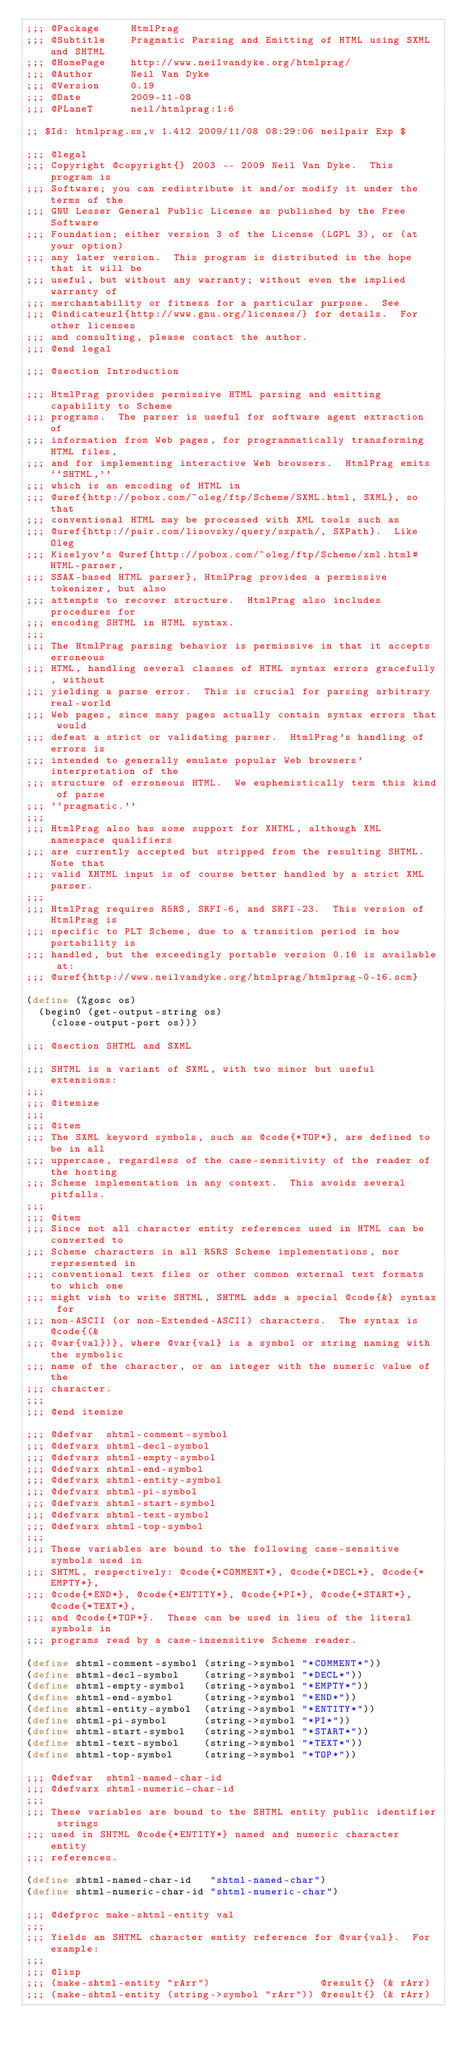Convert code to text. <code><loc_0><loc_0><loc_500><loc_500><_Scheme_>;;; @Package     HtmlPrag
;;; @Subtitle    Pragmatic Parsing and Emitting of HTML using SXML and SHTML
;;; @HomePage    http://www.neilvandyke.org/htmlprag/
;;; @Author      Neil Van Dyke
;;; @Version     0.19
;;; @Date        2009-11-08
;;; @PLaneT      neil/htmlprag:1:6

;; $Id: htmlprag.ss,v 1.412 2009/11/08 08:29:06 neilpair Exp $

;;; @legal
;;; Copyright @copyright{} 2003 -- 2009 Neil Van Dyke.  This program is
;;; Software; you can redistribute it and/or modify it under the terms of the
;;; GNU Lesser General Public License as published by the Free Software
;;; Foundation; either version 3 of the License (LGPL 3), or (at your option)
;;; any later version.  This program is distributed in the hope that it will be
;;; useful, but without any warranty; without even the implied warranty of
;;; merchantability or fitness for a particular purpose.  See
;;; @indicateurl{http://www.gnu.org/licenses/} for details.  For other licenses
;;; and consulting, please contact the author.
;;; @end legal

;;; @section Introduction

;;; HtmlPrag provides permissive HTML parsing and emitting capability to Scheme
;;; programs.  The parser is useful for software agent extraction of
;;; information from Web pages, for programmatically transforming HTML files,
;;; and for implementing interactive Web browsers.  HtmlPrag emits ``SHTML,''
;;; which is an encoding of HTML in
;;; @uref{http://pobox.com/~oleg/ftp/Scheme/SXML.html, SXML}, so that
;;; conventional HTML may be processed with XML tools such as
;;; @uref{http://pair.com/lisovsky/query/sxpath/, SXPath}.  Like Oleg
;;; Kiselyov's @uref{http://pobox.com/~oleg/ftp/Scheme/xml.html#HTML-parser,
;;; SSAX-based HTML parser}, HtmlPrag provides a permissive tokenizer, but also
;;; attempts to recover structure.  HtmlPrag also includes procedures for
;;; encoding SHTML in HTML syntax.
;;;
;;; The HtmlPrag parsing behavior is permissive in that it accepts erroneous
;;; HTML, handling several classes of HTML syntax errors gracefully, without
;;; yielding a parse error.  This is crucial for parsing arbitrary real-world
;;; Web pages, since many pages actually contain syntax errors that would
;;; defeat a strict or validating parser.  HtmlPrag's handling of errors is
;;; intended to generally emulate popular Web browsers' interpretation of the
;;; structure of erroneous HTML.  We euphemistically term this kind of parse
;;; ``pragmatic.''
;;;
;;; HtmlPrag also has some support for XHTML, although XML namespace qualifiers
;;; are currently accepted but stripped from the resulting SHTML.  Note that
;;; valid XHTML input is of course better handled by a strict XML parser.
;;;
;;; HtmlPrag requires R5RS, SRFI-6, and SRFI-23.  This version of HtmlPrag is
;;; specific to PLT Scheme, due to a transition period in how portability is
;;; handled, but the exceedingly portable version 0.16 is available at:
;;; @uref{http://www.neilvandyke.org/htmlprag/htmlprag-0-16.scm}

(define (%gosc os)
  (begin0 (get-output-string os)
    (close-output-port os)))

;;; @section SHTML and SXML

;;; SHTML is a variant of SXML, with two minor but useful extensions:
;;;
;;; @itemize
;;;
;;; @item
;;; The SXML keyword symbols, such as @code{*TOP*}, are defined to be in all
;;; uppercase, regardless of the case-sensitivity of the reader of the hosting
;;; Scheme implementation in any context.  This avoids several pitfalls.
;;;
;;; @item
;;; Since not all character entity references used in HTML can be converted to
;;; Scheme characters in all R5RS Scheme implementations, nor represented in
;;; conventional text files or other common external text formats to which one
;;; might wish to write SHTML, SHTML adds a special @code{&} syntax for
;;; non-ASCII (or non-Extended-ASCII) characters.  The syntax is @code{(&
;;; @var{val})}, where @var{val} is a symbol or string naming with the symbolic
;;; name of the character, or an integer with the numeric value of the
;;; character.
;;;
;;; @end itemize

;;; @defvar  shtml-comment-symbol
;;; @defvarx shtml-decl-symbol
;;; @defvarx shtml-empty-symbol
;;; @defvarx shtml-end-symbol
;;; @defvarx shtml-entity-symbol
;;; @defvarx shtml-pi-symbol
;;; @defvarx shtml-start-symbol
;;; @defvarx shtml-text-symbol
;;; @defvarx shtml-top-symbol
;;;
;;; These variables are bound to the following case-sensitive symbols used in
;;; SHTML, respectively: @code{*COMMENT*}, @code{*DECL*}, @code{*EMPTY*},
;;; @code{*END*}, @code{*ENTITY*}, @code{*PI*}, @code{*START*}, @code{*TEXT*},
;;; and @code{*TOP*}.  These can be used in lieu of the literal symbols in
;;; programs read by a case-insensitive Scheme reader.

(define shtml-comment-symbol (string->symbol "*COMMENT*"))
(define shtml-decl-symbol    (string->symbol "*DECL*"))
(define shtml-empty-symbol   (string->symbol "*EMPTY*"))
(define shtml-end-symbol     (string->symbol "*END*"))
(define shtml-entity-symbol  (string->symbol "*ENTITY*"))
(define shtml-pi-symbol      (string->symbol "*PI*"))
(define shtml-start-symbol   (string->symbol "*START*"))
(define shtml-text-symbol    (string->symbol "*TEXT*"))
(define shtml-top-symbol     (string->symbol "*TOP*"))

;;; @defvar  shtml-named-char-id
;;; @defvarx shtml-numeric-char-id
;;;
;;; These variables are bound to the SHTML entity public identifier strings
;;; used in SHTML @code{*ENTITY*} named and numeric character entity
;;; references.

(define shtml-named-char-id   "shtml-named-char")
(define shtml-numeric-char-id "shtml-numeric-char")

;;; @defproc make-shtml-entity val
;;;
;;; Yields an SHTML character entity reference for @var{val}.  For example:
;;;
;;; @lisp
;;; (make-shtml-entity "rArr")                  @result{} (& rArr)
;;; (make-shtml-entity (string->symbol "rArr")) @result{} (& rArr)</code> 